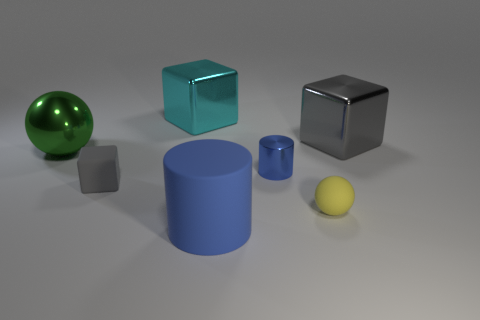Add 1 gray shiny cubes. How many objects exist? 8 Subtract all balls. How many objects are left? 5 Add 2 cyan shiny things. How many cyan shiny things are left? 3 Add 2 green shiny things. How many green shiny things exist? 3 Subtract 0 brown blocks. How many objects are left? 7 Subtract all green metallic balls. Subtract all small gray rubber blocks. How many objects are left? 5 